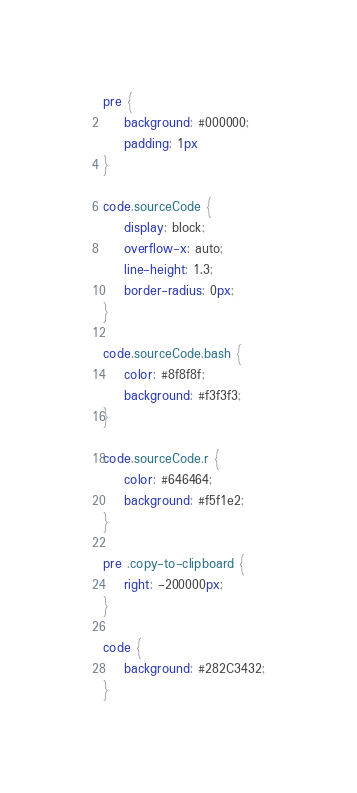Convert code to text. <code><loc_0><loc_0><loc_500><loc_500><_CSS_>pre {
    background: #000000;
    padding: 1px
}

code.sourceCode {
    display: block;
    overflow-x: auto;
    line-height: 1.3;
    border-radius: 0px;
}

code.sourceCode.bash {
    color: #8f8f8f;
    background: #f3f3f3;
}

code.sourceCode.r {
    color: #646464;
    background: #f5f1e2;
}

pre .copy-to-clipboard {
    right: -200000px;
}

code {
    background: #282C3432;
}
</code> 